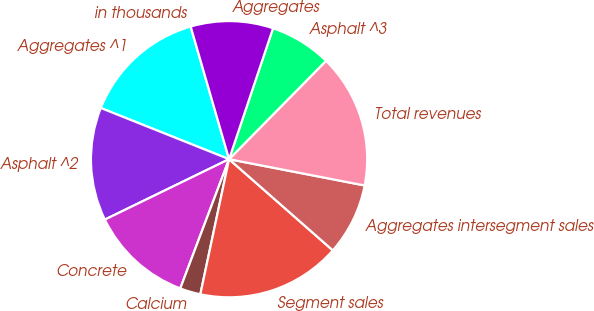<chart> <loc_0><loc_0><loc_500><loc_500><pie_chart><fcel>in thousands<fcel>Aggregates ^1<fcel>Asphalt ^2<fcel>Concrete<fcel>Calcium<fcel>Segment sales<fcel>Aggregates intersegment sales<fcel>Total revenues<fcel>Asphalt ^3<fcel>Aggregates<nl><fcel>0.01%<fcel>14.46%<fcel>13.25%<fcel>12.05%<fcel>2.41%<fcel>16.86%<fcel>8.43%<fcel>15.66%<fcel>7.23%<fcel>9.64%<nl></chart> 